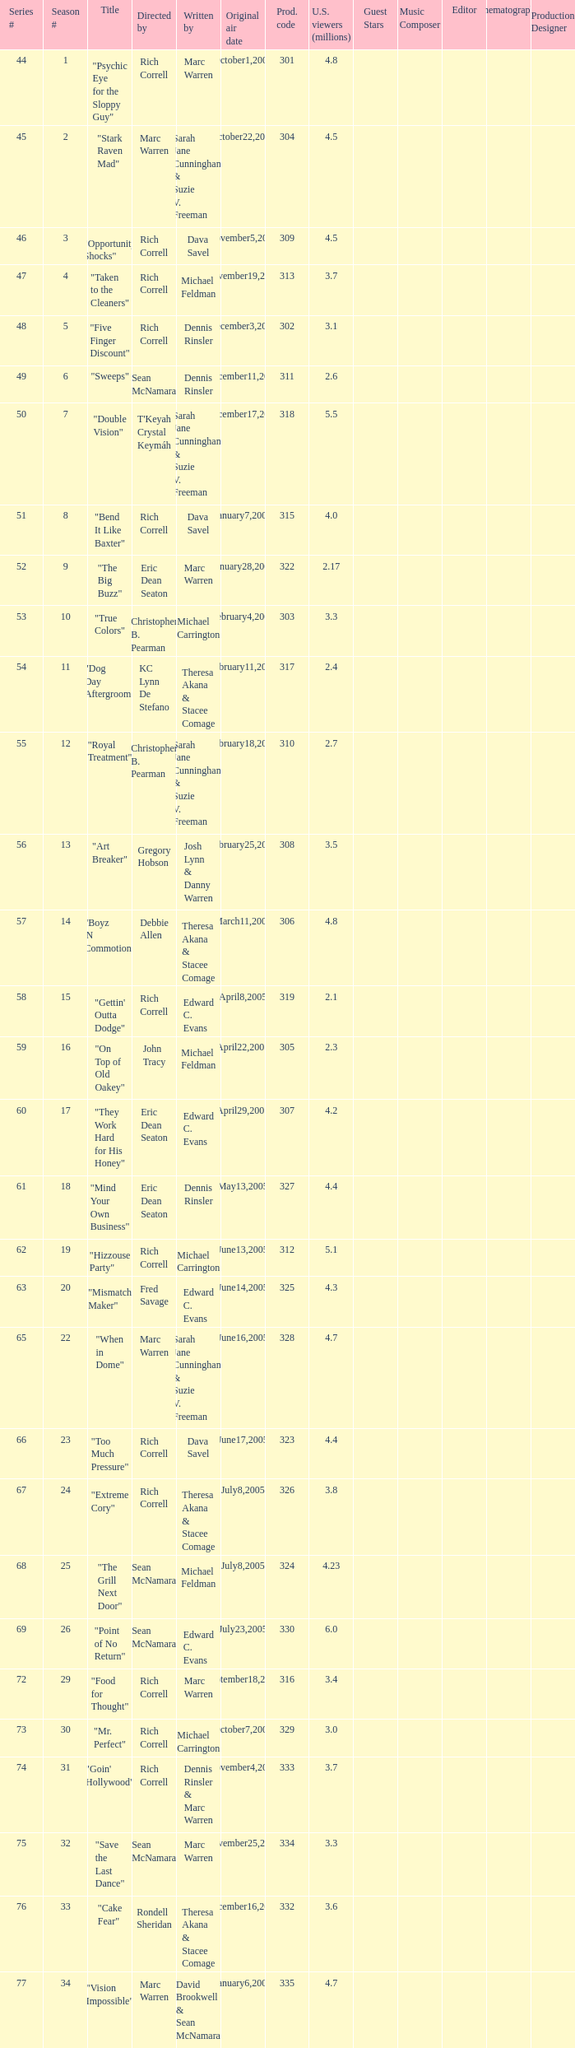What number episode of the season was titled "Vision Impossible"? 34.0. 